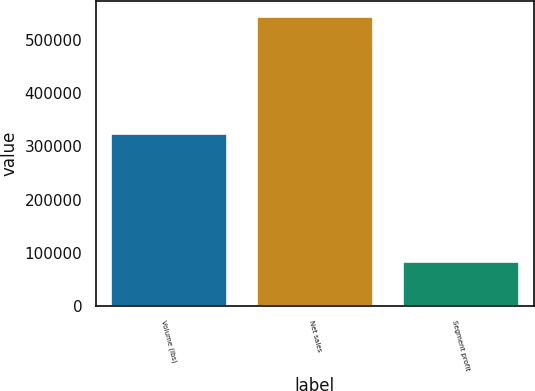<chart> <loc_0><loc_0><loc_500><loc_500><bar_chart><fcel>Volume (lbs)<fcel>Net sales<fcel>Segment profit<nl><fcel>324895<fcel>545014<fcel>85304<nl></chart> 